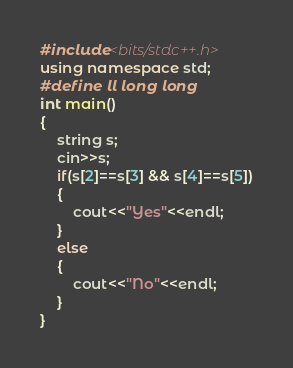<code> <loc_0><loc_0><loc_500><loc_500><_C++_>#include<bits/stdc++.h>
using namespace std;
#define ll long long
int main()
{
    string s;
    cin>>s;
    if(s[2]==s[3] && s[4]==s[5])
    {
        cout<<"Yes"<<endl;
    }
    else
    {
        cout<<"No"<<endl;
    }
}
</code> 